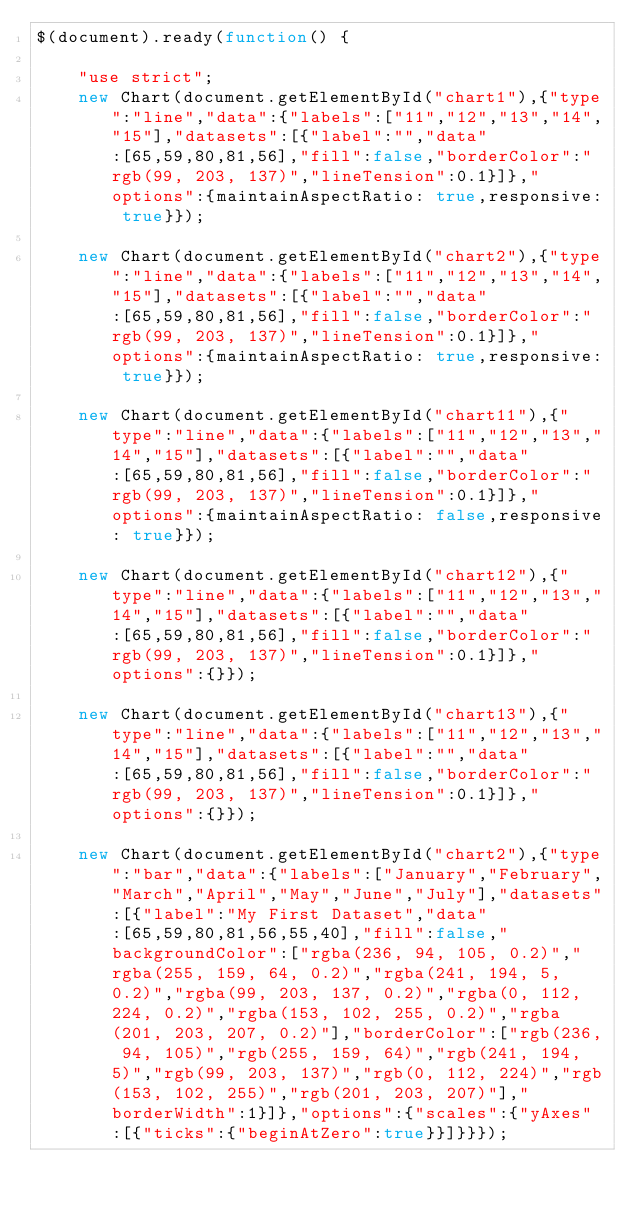<code> <loc_0><loc_0><loc_500><loc_500><_JavaScript_>$(document).ready(function() {
    
    "use strict";
    new Chart(document.getElementById("chart1"),{"type":"line","data":{"labels":["11","12","13","14","15"],"datasets":[{"label":"","data":[65,59,80,81,56],"fill":false,"borderColor":"rgb(99, 203, 137)","lineTension":0.1}]},"options":{maintainAspectRatio: true,responsive: true}});

    new Chart(document.getElementById("chart2"),{"type":"line","data":{"labels":["11","12","13","14","15"],"datasets":[{"label":"","data":[65,59,80,81,56],"fill":false,"borderColor":"rgb(99, 203, 137)","lineTension":0.1}]},"options":{maintainAspectRatio: true,responsive: true}});

    new Chart(document.getElementById("chart11"),{"type":"line","data":{"labels":["11","12","13","14","15"],"datasets":[{"label":"","data":[65,59,80,81,56],"fill":false,"borderColor":"rgb(99, 203, 137)","lineTension":0.1}]},"options":{maintainAspectRatio: false,responsive: true}});

    new Chart(document.getElementById("chart12"),{"type":"line","data":{"labels":["11","12","13","14","15"],"datasets":[{"label":"","data":[65,59,80,81,56],"fill":false,"borderColor":"rgb(99, 203, 137)","lineTension":0.1}]},"options":{}});

    new Chart(document.getElementById("chart13"),{"type":"line","data":{"labels":["11","12","13","14","15"],"datasets":[{"label":"","data":[65,59,80,81,56],"fill":false,"borderColor":"rgb(99, 203, 137)","lineTension":0.1}]},"options":{}});
    
    new Chart(document.getElementById("chart2"),{"type":"bar","data":{"labels":["January","February","March","April","May","June","July"],"datasets":[{"label":"My First Dataset","data":[65,59,80,81,56,55,40],"fill":false,"backgroundColor":["rgba(236, 94, 105, 0.2)","rgba(255, 159, 64, 0.2)","rgba(241, 194, 5, 0.2)","rgba(99, 203, 137, 0.2)","rgba(0, 112, 224, 0.2)","rgba(153, 102, 255, 0.2)","rgba(201, 203, 207, 0.2)"],"borderColor":["rgb(236, 94, 105)","rgb(255, 159, 64)","rgb(241, 194, 5)","rgb(99, 203, 137)","rgb(0, 112, 224)","rgb(153, 102, 255)","rgb(201, 203, 207)"],"borderWidth":1}]},"options":{"scales":{"yAxes":[{"ticks":{"beginAtZero":true}}]}}});
    </code> 